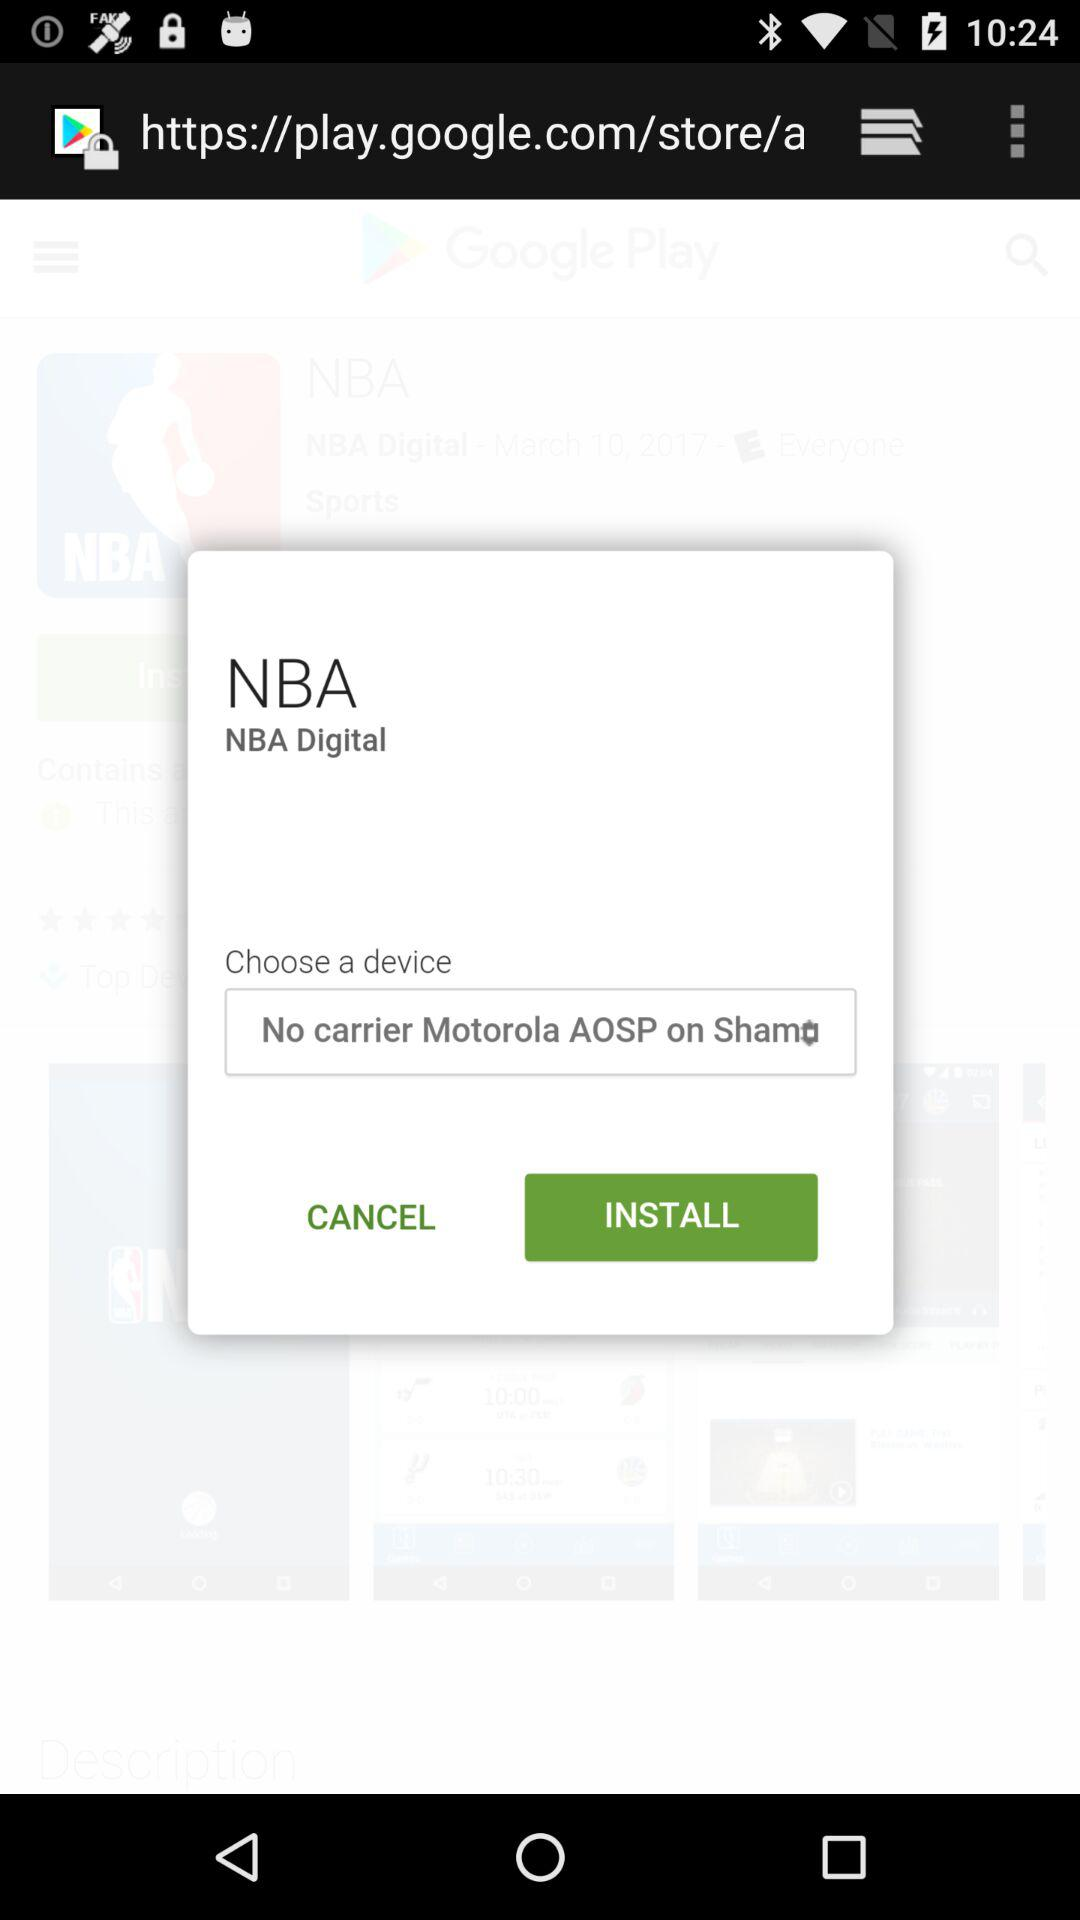What option is selected in "Choose a device"? The option selected in "Choose a device" is "No carrier Motorola AOSP on Shamo". 